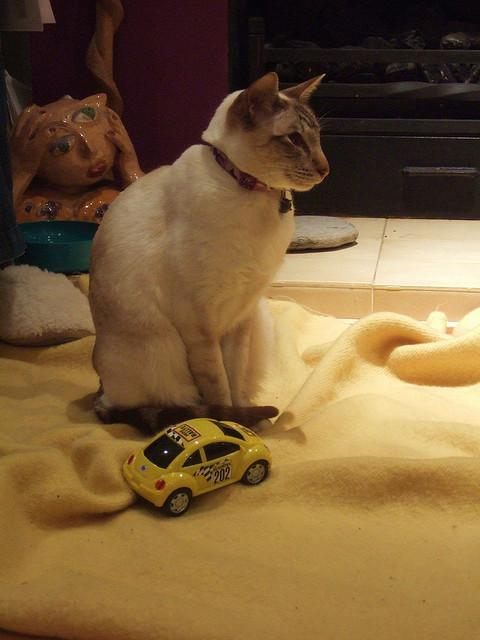What room is it? Please explain your reasoning. family room. There is a toy car by the cat. 